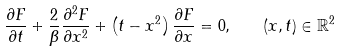Convert formula to latex. <formula><loc_0><loc_0><loc_500><loc_500>\frac { \partial F } { \partial t } + \frac { 2 } { \beta } \frac { \partial ^ { 2 } F } { \partial x ^ { 2 } } + \left ( t - x ^ { 2 } \right ) \frac { \partial F } { \partial x } = 0 , \quad ( x , t ) \in { \mathbb { R } } ^ { 2 }</formula> 